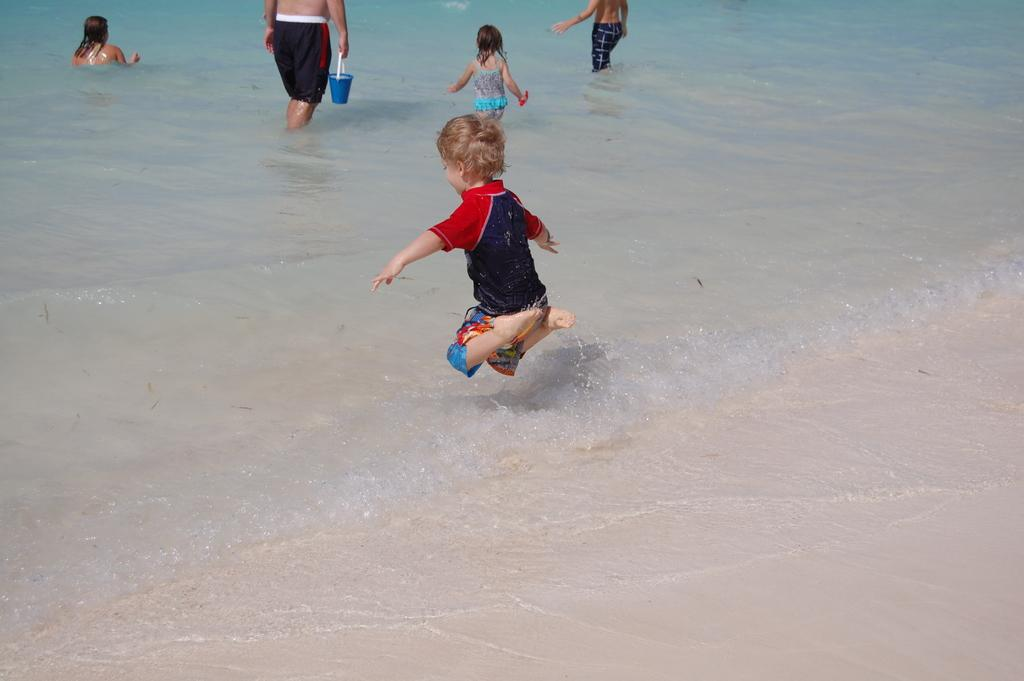What is the boy doing in the image? The boy is jumping in the image. What are the other people in the image doing? There is a man standing in the water, two girls standing in the water, and a woman sitting in the water. Where does the image appear to be set? The image appears to be at a seashore. What is happening with the water in the image? Water is flowing in the image. Where is the throne located in the image? There is no throne present in the image. 